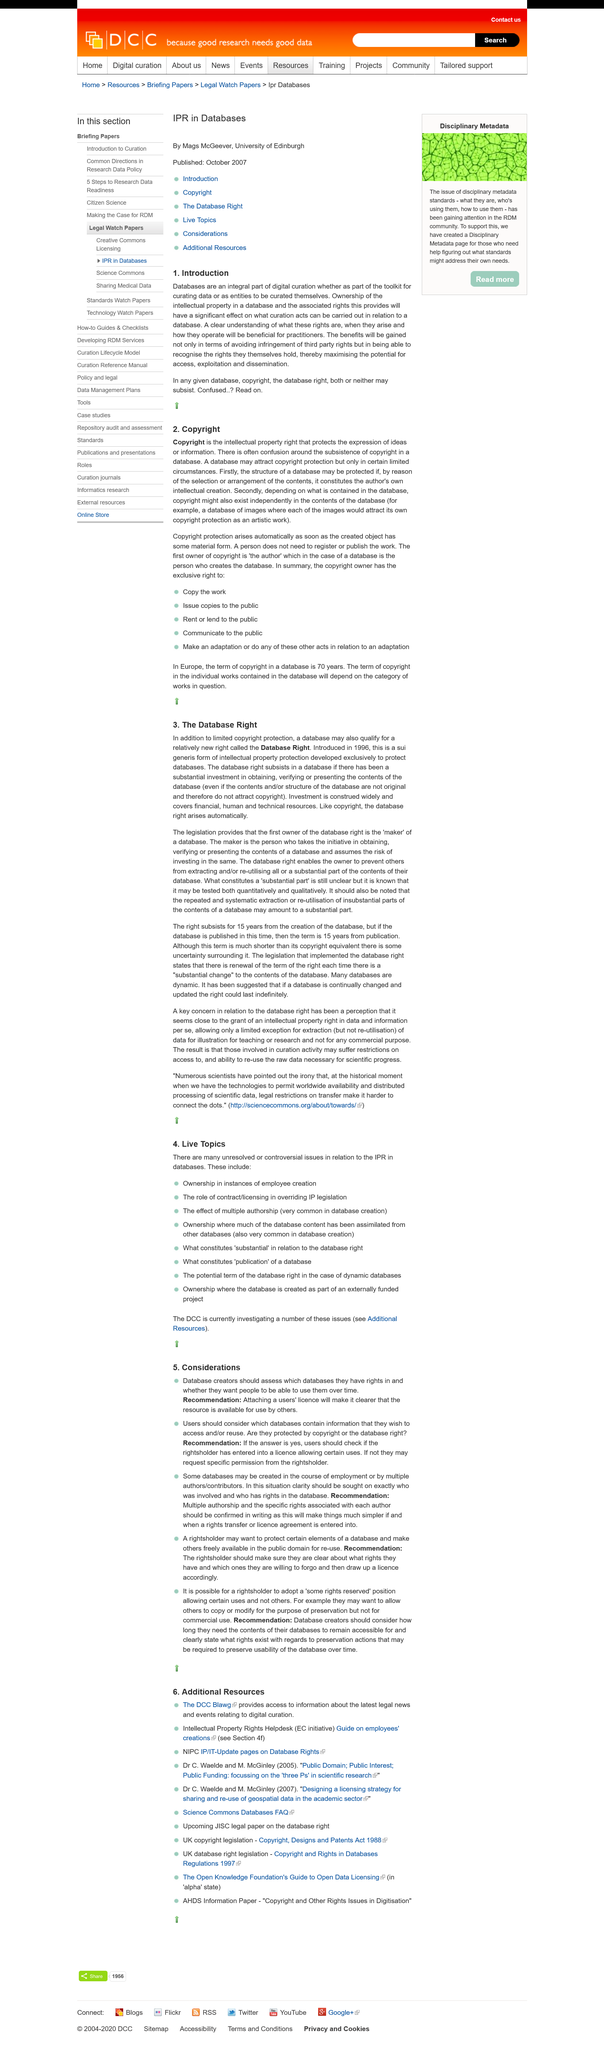Outline some significant characteristics in this image. The copyright of the database is the subject of paragraph number two (2). Databases are a crucial component of digital curation, as they provide a structured and organized means of storing and managing digital data. This page is about the concept of database right. If an individual wishes to use a database without a license, they may seek specific permission from the rightsholder. It is important for a database to be available for use by others, and this can be achieved by attaching a user's license to it, which makes it clear that the resource is intended for use by other users. 